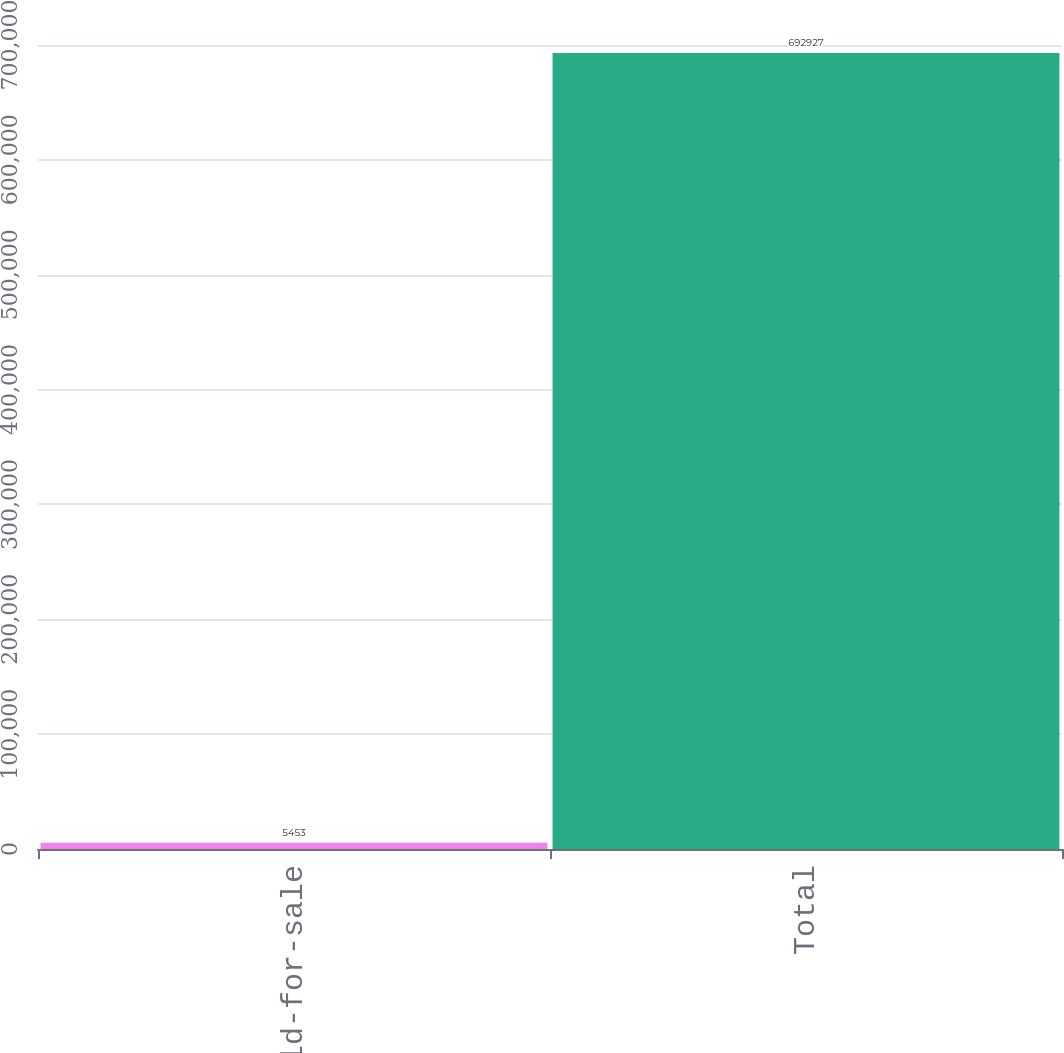Convert chart. <chart><loc_0><loc_0><loc_500><loc_500><bar_chart><fcel>Held-for-sale<fcel>Total<nl><fcel>5453<fcel>692927<nl></chart> 